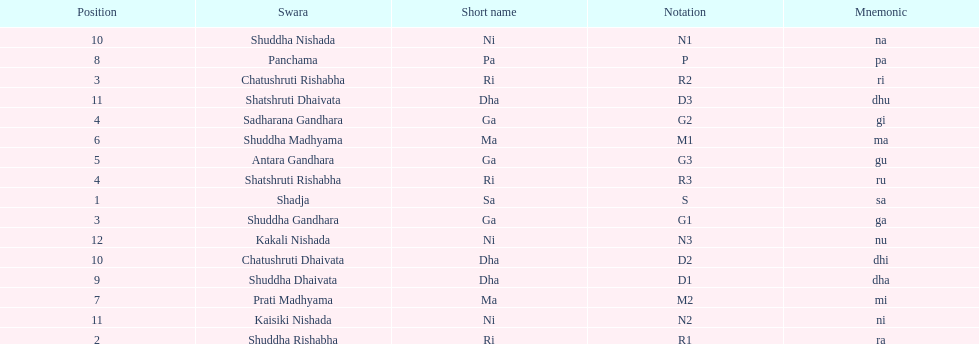What is the total number of positions listed? 16. 